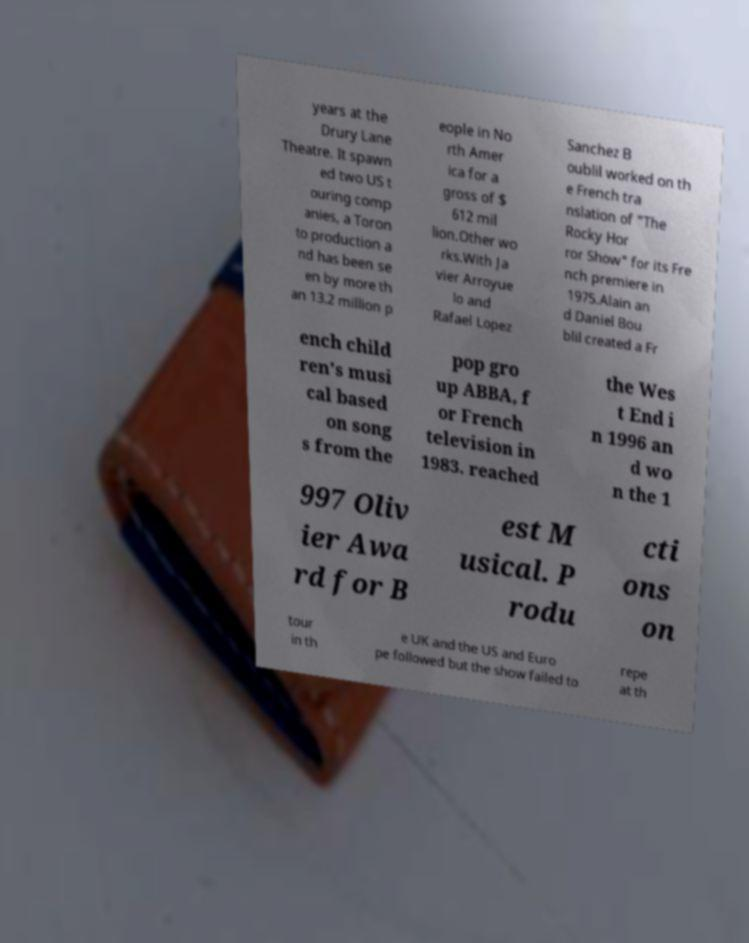Could you assist in decoding the text presented in this image and type it out clearly? years at the Drury Lane Theatre. It spawn ed two US t ouring comp anies, a Toron to production a nd has been se en by more th an 13.2 million p eople in No rth Amer ica for a gross of $ 612 mil lion.Other wo rks.With Ja vier Arroyue lo and Rafael Lopez Sanchez B oublil worked on th e French tra nslation of "The Rocky Hor ror Show" for its Fre nch premiere in 1975.Alain an d Daniel Bou blil created a Fr ench child ren's musi cal based on song s from the pop gro up ABBA, f or French television in 1983. reached the Wes t End i n 1996 an d wo n the 1 997 Oliv ier Awa rd for B est M usical. P rodu cti ons on tour in th e UK and the US and Euro pe followed but the show failed to repe at th 